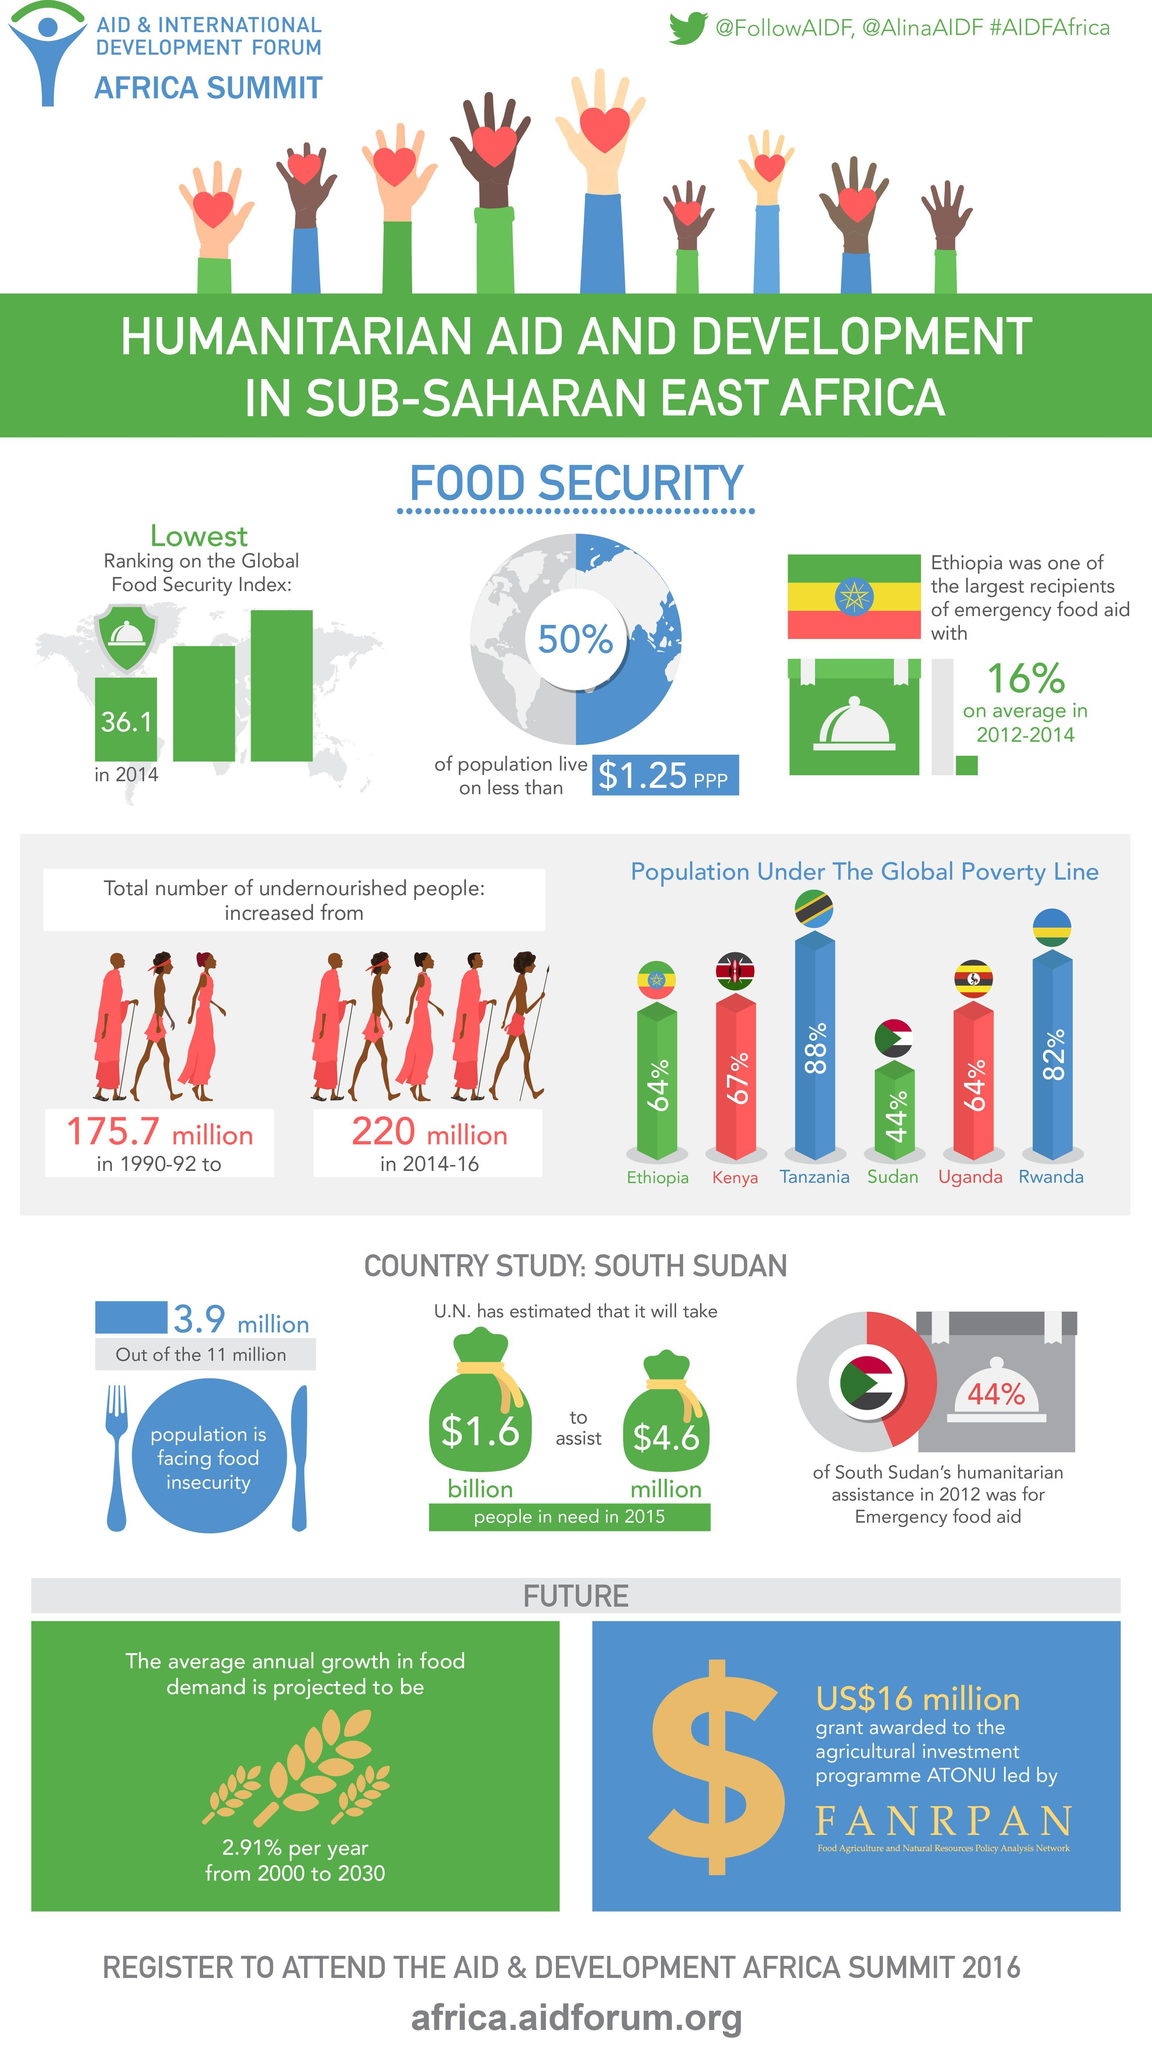What is the difference between undernourished people in 2014-16 to 1990-92?
Answer the question with a short phrase. 44.3 million How many countries under the global poverty line are in this infographic? 6 What percentage of South Sudan's humanitarian assistance in 2012 was not for emergency food aid? 56% 